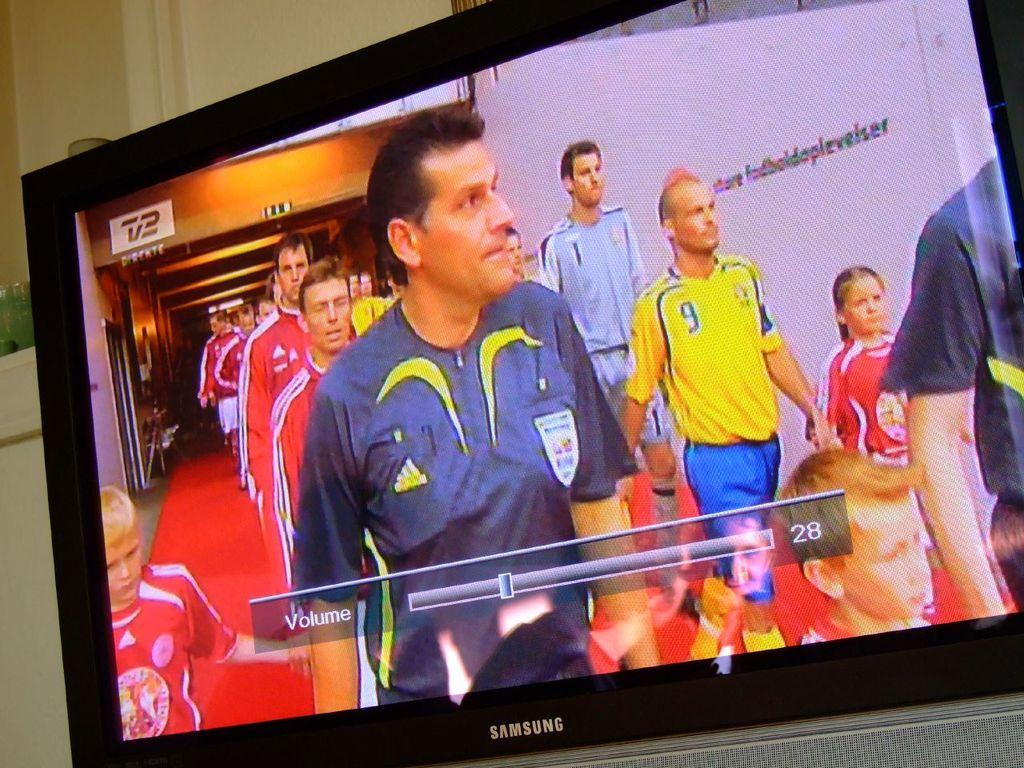<image>
Write a terse but informative summary of the picture. A samsung branded laptop screen displaying a soccer player with an adidas branded shirt. 